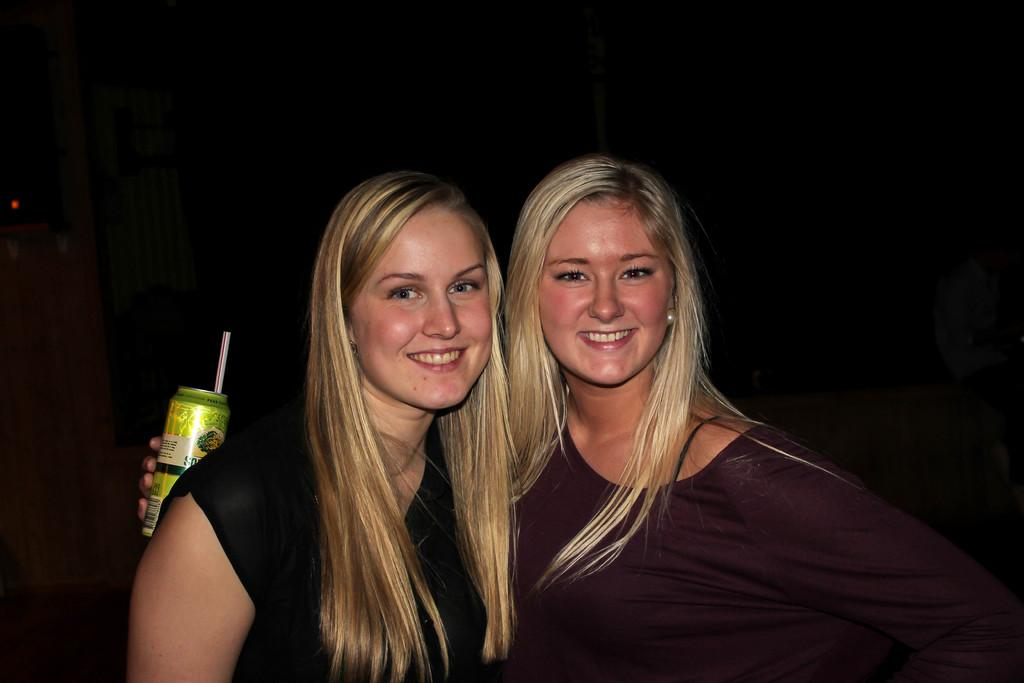How many people are in the image? There are two women in the image. What expressions do the women have? The women are smiling. Can you describe the background of the image? The background of the image is dark. What type of iron can be seen in the image? There is no iron present in the image. What letter is being held by one of the women in the image? There is no letter being held by either of the women in the image. 